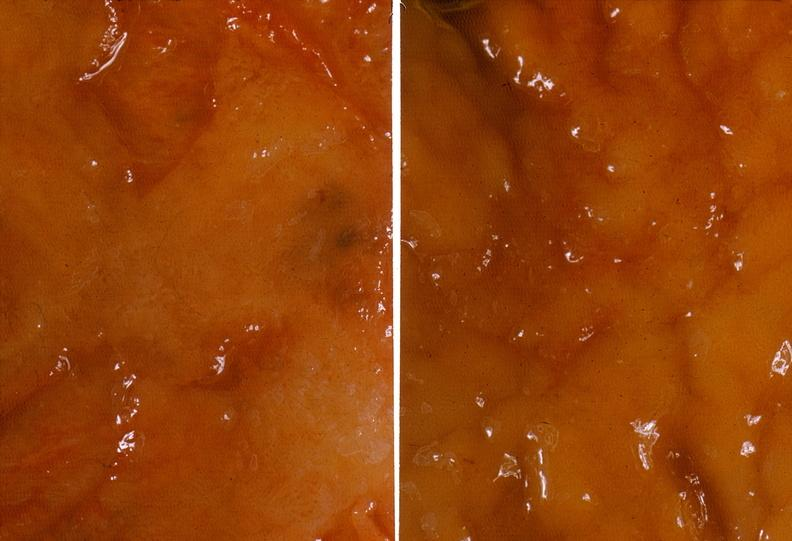does case of dic not bad photo show colon, ulcerative colitis, mucosal detail?
Answer the question using a single word or phrase. No 